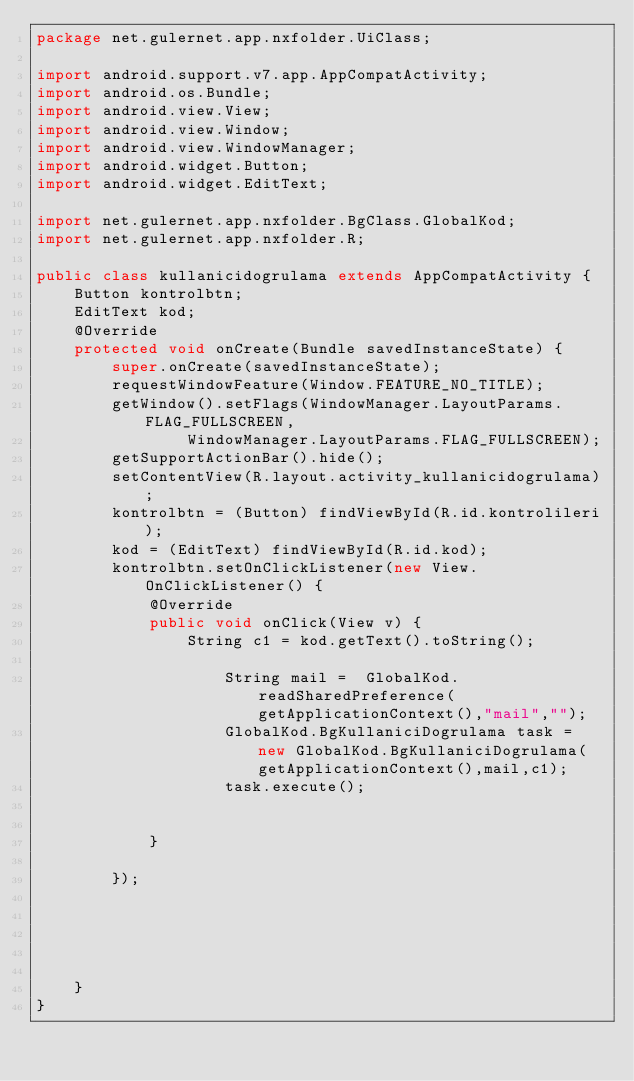<code> <loc_0><loc_0><loc_500><loc_500><_Java_>package net.gulernet.app.nxfolder.UiClass;

import android.support.v7.app.AppCompatActivity;
import android.os.Bundle;
import android.view.View;
import android.view.Window;
import android.view.WindowManager;
import android.widget.Button;
import android.widget.EditText;

import net.gulernet.app.nxfolder.BgClass.GlobalKod;
import net.gulernet.app.nxfolder.R;

public class kullanicidogrulama extends AppCompatActivity {
    Button kontrolbtn;
    EditText kod;
    @Override
    protected void onCreate(Bundle savedInstanceState) {
        super.onCreate(savedInstanceState);
        requestWindowFeature(Window.FEATURE_NO_TITLE);
        getWindow().setFlags(WindowManager.LayoutParams.FLAG_FULLSCREEN,
                WindowManager.LayoutParams.FLAG_FULLSCREEN);
        getSupportActionBar().hide();
        setContentView(R.layout.activity_kullanicidogrulama);
        kontrolbtn = (Button) findViewById(R.id.kontrolileri);
        kod = (EditText) findViewById(R.id.kod);
        kontrolbtn.setOnClickListener(new View.OnClickListener() {
            @Override
            public void onClick(View v) {
                String c1 = kod.getText().toString();

                    String mail =  GlobalKod.readSharedPreference(getApplicationContext(),"mail","");
                    GlobalKod.BgKullaniciDogrulama task = new GlobalKod.BgKullaniciDogrulama(getApplicationContext(),mail,c1);
                    task.execute();


            }

        });





    }
}
</code> 